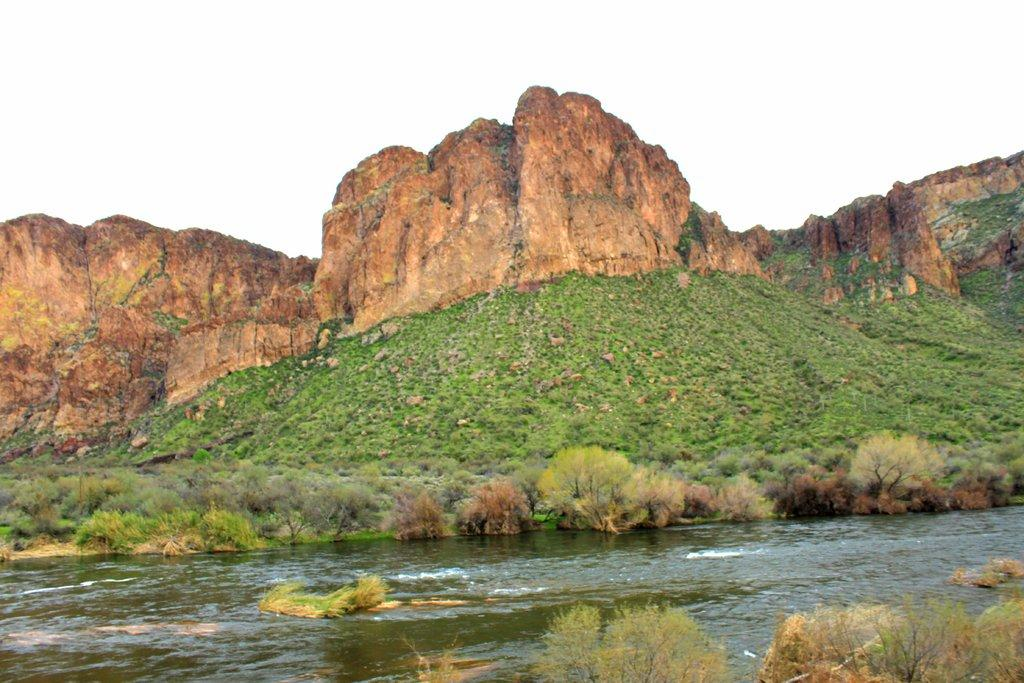What is the primary element visible in the image? Water is visible in the image. What type of vegetation can be seen in the image? There are many plants and grass in the image. What type of geological formation is present in the image? There are rocky mountains in the image. What is the condition of the sky in the background of the image? The sky is clear in the background of the image. What type of oatmeal is being prepared in the image? There is no oatmeal present in the image. How many eggs are visible in the image? There are no eggs visible in the image. 